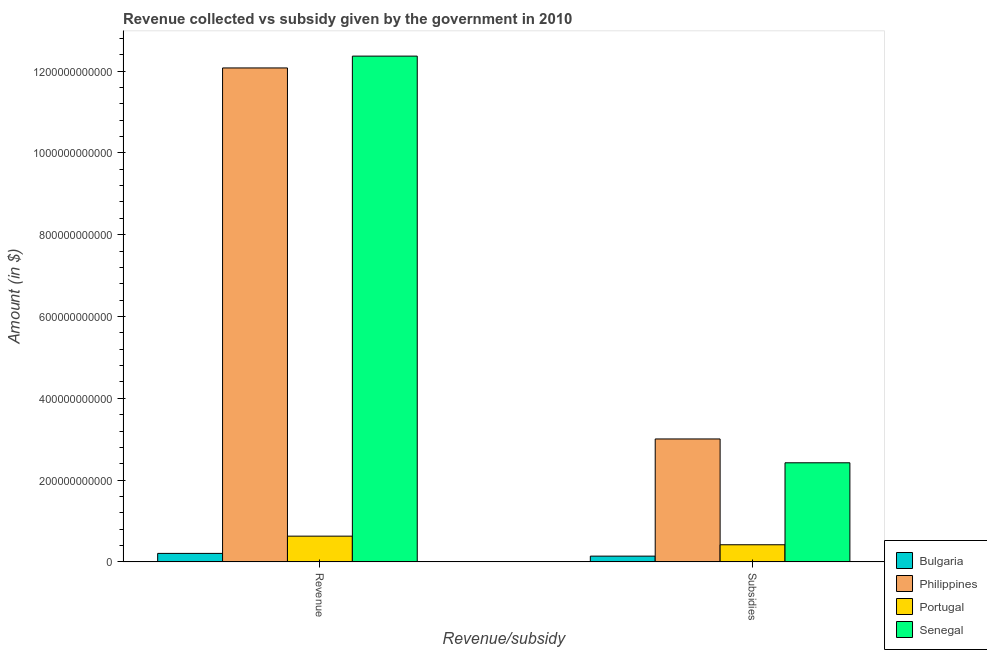How many different coloured bars are there?
Offer a very short reply. 4. How many groups of bars are there?
Make the answer very short. 2. Are the number of bars per tick equal to the number of legend labels?
Give a very brief answer. Yes. How many bars are there on the 2nd tick from the right?
Your answer should be compact. 4. What is the label of the 2nd group of bars from the left?
Offer a very short reply. Subsidies. What is the amount of subsidies given in Senegal?
Ensure brevity in your answer.  2.42e+11. Across all countries, what is the maximum amount of subsidies given?
Ensure brevity in your answer.  3.01e+11. Across all countries, what is the minimum amount of revenue collected?
Offer a terse response. 2.08e+1. In which country was the amount of revenue collected maximum?
Provide a short and direct response. Senegal. What is the total amount of subsidies given in the graph?
Give a very brief answer. 5.99e+11. What is the difference between the amount of subsidies given in Bulgaria and that in Portugal?
Your response must be concise. -2.78e+1. What is the difference between the amount of subsidies given in Bulgaria and the amount of revenue collected in Senegal?
Your answer should be compact. -1.22e+12. What is the average amount of revenue collected per country?
Your response must be concise. 6.32e+11. What is the difference between the amount of revenue collected and amount of subsidies given in Philippines?
Give a very brief answer. 9.07e+11. What is the ratio of the amount of revenue collected in Philippines to that in Portugal?
Provide a short and direct response. 19.18. Is the amount of revenue collected in Philippines less than that in Portugal?
Your response must be concise. No. What does the 1st bar from the right in Subsidies represents?
Offer a very short reply. Senegal. How many countries are there in the graph?
Give a very brief answer. 4. What is the difference between two consecutive major ticks on the Y-axis?
Make the answer very short. 2.00e+11. Does the graph contain grids?
Provide a short and direct response. No. Where does the legend appear in the graph?
Your answer should be compact. Bottom right. What is the title of the graph?
Your response must be concise. Revenue collected vs subsidy given by the government in 2010. What is the label or title of the X-axis?
Your response must be concise. Revenue/subsidy. What is the label or title of the Y-axis?
Provide a succinct answer. Amount (in $). What is the Amount (in $) in Bulgaria in Revenue?
Ensure brevity in your answer.  2.08e+1. What is the Amount (in $) in Philippines in Revenue?
Offer a terse response. 1.21e+12. What is the Amount (in $) in Portugal in Revenue?
Offer a very short reply. 6.30e+1. What is the Amount (in $) in Senegal in Revenue?
Make the answer very short. 1.24e+12. What is the Amount (in $) in Bulgaria in Subsidies?
Your answer should be compact. 1.41e+1. What is the Amount (in $) in Philippines in Subsidies?
Offer a very short reply. 3.01e+11. What is the Amount (in $) in Portugal in Subsidies?
Offer a very short reply. 4.19e+1. What is the Amount (in $) of Senegal in Subsidies?
Give a very brief answer. 2.42e+11. Across all Revenue/subsidy, what is the maximum Amount (in $) in Bulgaria?
Your answer should be very brief. 2.08e+1. Across all Revenue/subsidy, what is the maximum Amount (in $) in Philippines?
Your response must be concise. 1.21e+12. Across all Revenue/subsidy, what is the maximum Amount (in $) of Portugal?
Your answer should be very brief. 6.30e+1. Across all Revenue/subsidy, what is the maximum Amount (in $) of Senegal?
Your answer should be very brief. 1.24e+12. Across all Revenue/subsidy, what is the minimum Amount (in $) of Bulgaria?
Give a very brief answer. 1.41e+1. Across all Revenue/subsidy, what is the minimum Amount (in $) in Philippines?
Your answer should be very brief. 3.01e+11. Across all Revenue/subsidy, what is the minimum Amount (in $) in Portugal?
Make the answer very short. 4.19e+1. Across all Revenue/subsidy, what is the minimum Amount (in $) of Senegal?
Provide a short and direct response. 2.42e+11. What is the total Amount (in $) of Bulgaria in the graph?
Provide a short and direct response. 3.49e+1. What is the total Amount (in $) in Philippines in the graph?
Make the answer very short. 1.51e+12. What is the total Amount (in $) of Portugal in the graph?
Provide a short and direct response. 1.05e+11. What is the total Amount (in $) in Senegal in the graph?
Your answer should be very brief. 1.48e+12. What is the difference between the Amount (in $) of Bulgaria in Revenue and that in Subsidies?
Keep it short and to the point. 6.69e+09. What is the difference between the Amount (in $) of Philippines in Revenue and that in Subsidies?
Provide a short and direct response. 9.07e+11. What is the difference between the Amount (in $) in Portugal in Revenue and that in Subsidies?
Your response must be concise. 2.10e+1. What is the difference between the Amount (in $) in Senegal in Revenue and that in Subsidies?
Your answer should be very brief. 9.94e+11. What is the difference between the Amount (in $) in Bulgaria in Revenue and the Amount (in $) in Philippines in Subsidies?
Your answer should be compact. -2.80e+11. What is the difference between the Amount (in $) of Bulgaria in Revenue and the Amount (in $) of Portugal in Subsidies?
Your answer should be compact. -2.11e+1. What is the difference between the Amount (in $) in Bulgaria in Revenue and the Amount (in $) in Senegal in Subsidies?
Give a very brief answer. -2.22e+11. What is the difference between the Amount (in $) of Philippines in Revenue and the Amount (in $) of Portugal in Subsidies?
Give a very brief answer. 1.17e+12. What is the difference between the Amount (in $) of Philippines in Revenue and the Amount (in $) of Senegal in Subsidies?
Your answer should be compact. 9.65e+11. What is the difference between the Amount (in $) of Portugal in Revenue and the Amount (in $) of Senegal in Subsidies?
Your answer should be compact. -1.79e+11. What is the average Amount (in $) in Bulgaria per Revenue/subsidy?
Your answer should be very brief. 1.75e+1. What is the average Amount (in $) of Philippines per Revenue/subsidy?
Make the answer very short. 7.54e+11. What is the average Amount (in $) of Portugal per Revenue/subsidy?
Keep it short and to the point. 5.24e+1. What is the average Amount (in $) in Senegal per Revenue/subsidy?
Give a very brief answer. 7.39e+11. What is the difference between the Amount (in $) in Bulgaria and Amount (in $) in Philippines in Revenue?
Your answer should be compact. -1.19e+12. What is the difference between the Amount (in $) in Bulgaria and Amount (in $) in Portugal in Revenue?
Keep it short and to the point. -4.22e+1. What is the difference between the Amount (in $) in Bulgaria and Amount (in $) in Senegal in Revenue?
Provide a succinct answer. -1.22e+12. What is the difference between the Amount (in $) of Philippines and Amount (in $) of Portugal in Revenue?
Your answer should be very brief. 1.14e+12. What is the difference between the Amount (in $) of Philippines and Amount (in $) of Senegal in Revenue?
Provide a succinct answer. -2.89e+1. What is the difference between the Amount (in $) in Portugal and Amount (in $) in Senegal in Revenue?
Ensure brevity in your answer.  -1.17e+12. What is the difference between the Amount (in $) in Bulgaria and Amount (in $) in Philippines in Subsidies?
Keep it short and to the point. -2.86e+11. What is the difference between the Amount (in $) in Bulgaria and Amount (in $) in Portugal in Subsidies?
Keep it short and to the point. -2.78e+1. What is the difference between the Amount (in $) of Bulgaria and Amount (in $) of Senegal in Subsidies?
Provide a succinct answer. -2.28e+11. What is the difference between the Amount (in $) of Philippines and Amount (in $) of Portugal in Subsidies?
Provide a succinct answer. 2.59e+11. What is the difference between the Amount (in $) of Philippines and Amount (in $) of Senegal in Subsidies?
Your answer should be very brief. 5.83e+1. What is the difference between the Amount (in $) of Portugal and Amount (in $) of Senegal in Subsidies?
Provide a short and direct response. -2.00e+11. What is the ratio of the Amount (in $) of Bulgaria in Revenue to that in Subsidies?
Your response must be concise. 1.47. What is the ratio of the Amount (in $) of Philippines in Revenue to that in Subsidies?
Provide a short and direct response. 4.02. What is the ratio of the Amount (in $) in Portugal in Revenue to that in Subsidies?
Ensure brevity in your answer.  1.5. What is the ratio of the Amount (in $) in Senegal in Revenue to that in Subsidies?
Provide a succinct answer. 5.1. What is the difference between the highest and the second highest Amount (in $) of Bulgaria?
Your answer should be compact. 6.69e+09. What is the difference between the highest and the second highest Amount (in $) in Philippines?
Provide a short and direct response. 9.07e+11. What is the difference between the highest and the second highest Amount (in $) in Portugal?
Ensure brevity in your answer.  2.10e+1. What is the difference between the highest and the second highest Amount (in $) in Senegal?
Your response must be concise. 9.94e+11. What is the difference between the highest and the lowest Amount (in $) of Bulgaria?
Make the answer very short. 6.69e+09. What is the difference between the highest and the lowest Amount (in $) in Philippines?
Make the answer very short. 9.07e+11. What is the difference between the highest and the lowest Amount (in $) of Portugal?
Your response must be concise. 2.10e+1. What is the difference between the highest and the lowest Amount (in $) of Senegal?
Offer a very short reply. 9.94e+11. 